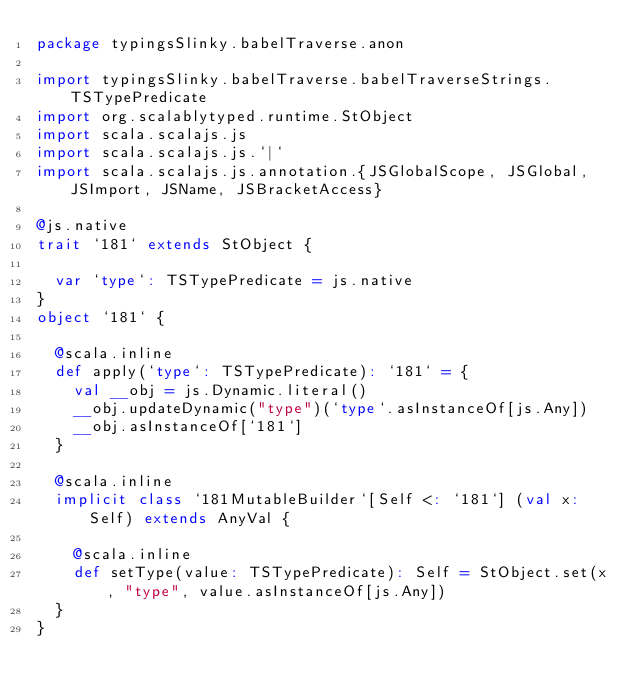<code> <loc_0><loc_0><loc_500><loc_500><_Scala_>package typingsSlinky.babelTraverse.anon

import typingsSlinky.babelTraverse.babelTraverseStrings.TSTypePredicate
import org.scalablytyped.runtime.StObject
import scala.scalajs.js
import scala.scalajs.js.`|`
import scala.scalajs.js.annotation.{JSGlobalScope, JSGlobal, JSImport, JSName, JSBracketAccess}

@js.native
trait `181` extends StObject {
  
  var `type`: TSTypePredicate = js.native
}
object `181` {
  
  @scala.inline
  def apply(`type`: TSTypePredicate): `181` = {
    val __obj = js.Dynamic.literal()
    __obj.updateDynamic("type")(`type`.asInstanceOf[js.Any])
    __obj.asInstanceOf[`181`]
  }
  
  @scala.inline
  implicit class `181MutableBuilder`[Self <: `181`] (val x: Self) extends AnyVal {
    
    @scala.inline
    def setType(value: TSTypePredicate): Self = StObject.set(x, "type", value.asInstanceOf[js.Any])
  }
}
</code> 